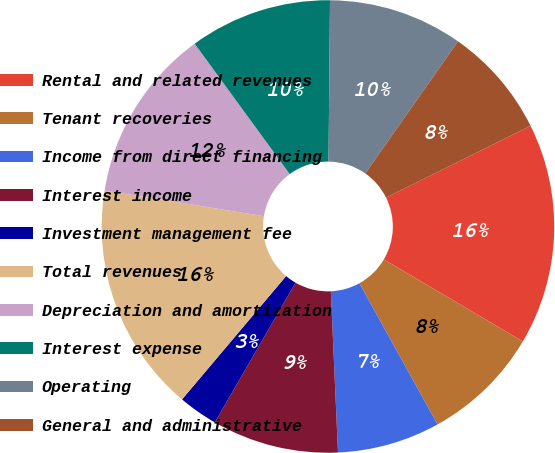Convert chart. <chart><loc_0><loc_0><loc_500><loc_500><pie_chart><fcel>Rental and related revenues<fcel>Tenant recoveries<fcel>Income from direct financing<fcel>Interest income<fcel>Investment management fee<fcel>Total revenues<fcel>Depreciation and amortization<fcel>Interest expense<fcel>Operating<fcel>General and administrative<nl><fcel>15.82%<fcel>8.47%<fcel>7.34%<fcel>9.04%<fcel>2.82%<fcel>16.38%<fcel>12.43%<fcel>10.17%<fcel>9.6%<fcel>7.91%<nl></chart> 